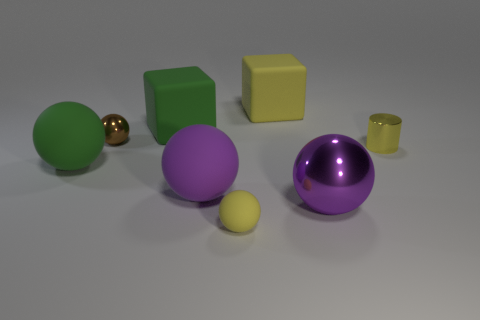Subtract all red blocks. How many purple spheres are left? 2 Subtract all brown balls. How many balls are left? 4 Add 1 yellow spheres. How many objects exist? 9 Subtract all green balls. How many balls are left? 4 Subtract all gray spheres. Subtract all cyan cylinders. How many spheres are left? 5 Subtract all cylinders. How many objects are left? 7 Add 7 large shiny balls. How many large shiny balls are left? 8 Add 4 large yellow rubber cubes. How many large yellow rubber cubes exist? 5 Subtract 0 brown cylinders. How many objects are left? 8 Subtract all small yellow rubber spheres. Subtract all shiny cylinders. How many objects are left? 6 